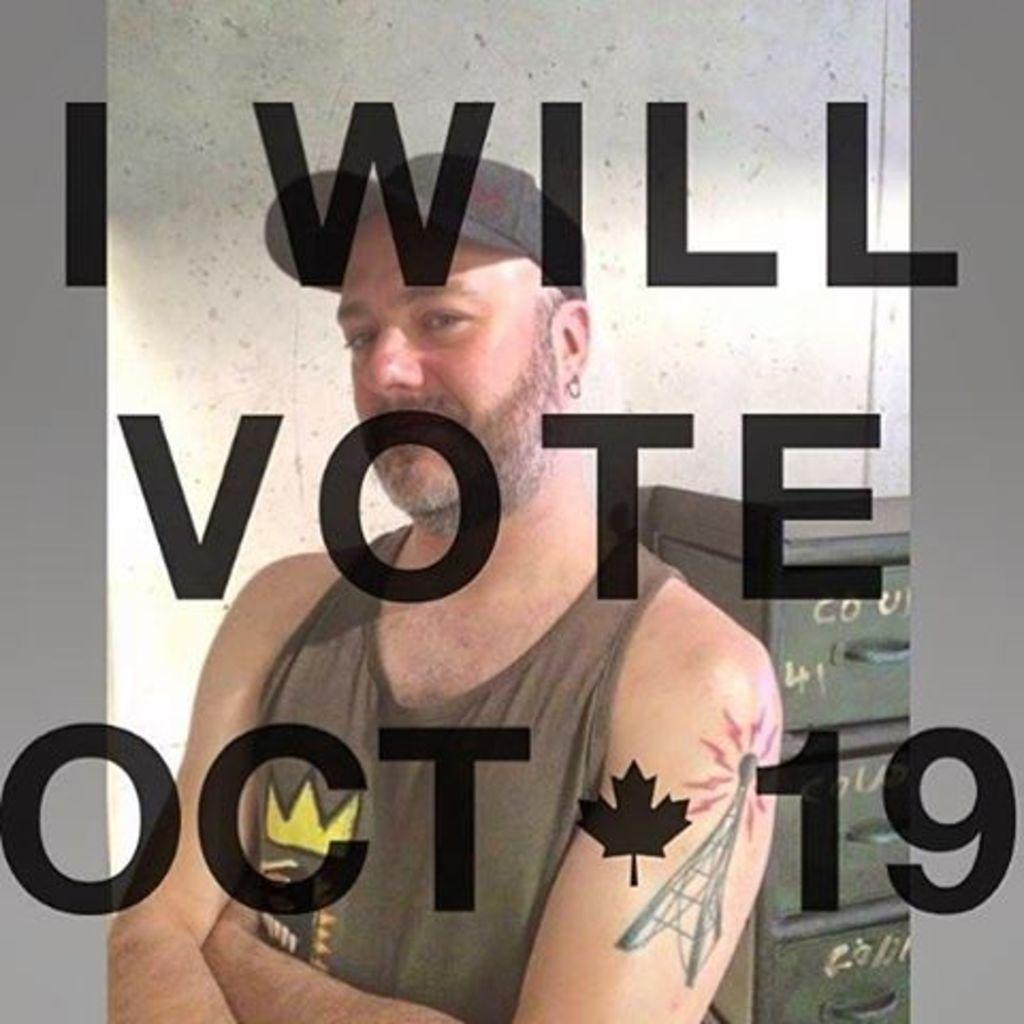Please provide a concise description of this image. In this image in front there is a person. Behind him there is a wall. On the right side of the image there is a rack. There is some text in front of the image. 